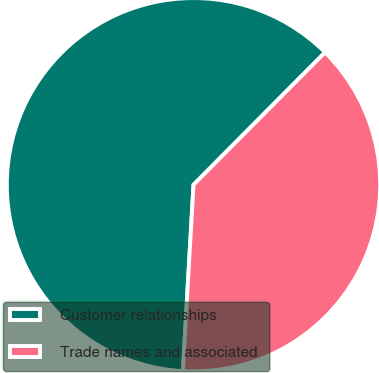Convert chart. <chart><loc_0><loc_0><loc_500><loc_500><pie_chart><fcel>Customer relationships<fcel>Trade names and associated<nl><fcel>61.54%<fcel>38.46%<nl></chart> 